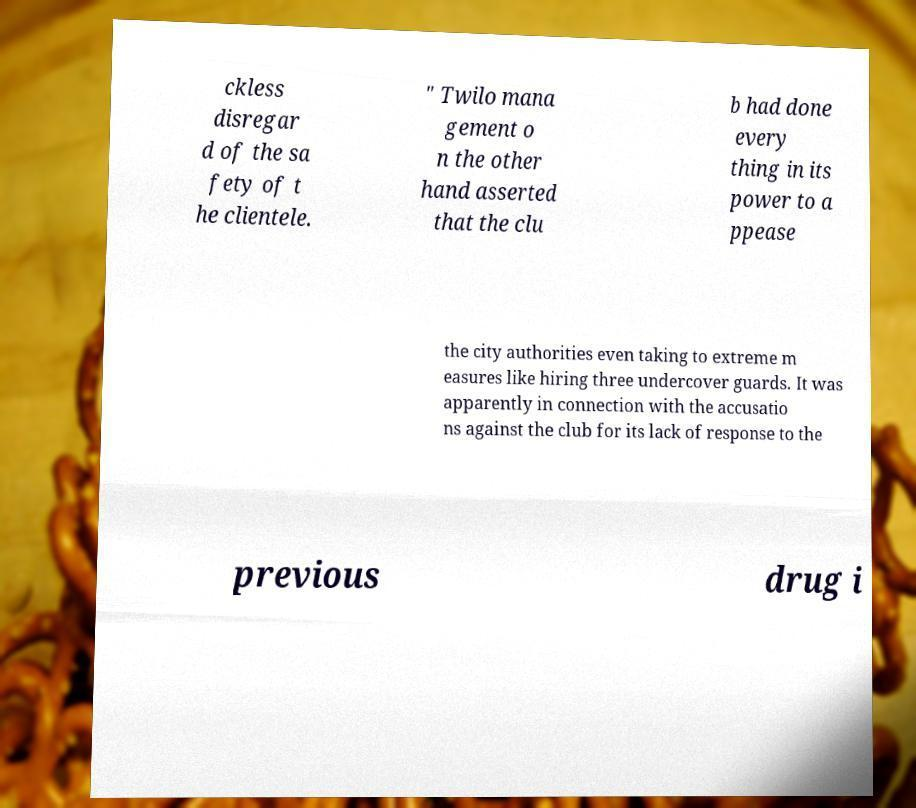Could you assist in decoding the text presented in this image and type it out clearly? ckless disregar d of the sa fety of t he clientele. " Twilo mana gement o n the other hand asserted that the clu b had done every thing in its power to a ppease the city authorities even taking to extreme m easures like hiring three undercover guards. It was apparently in connection with the accusatio ns against the club for its lack of response to the previous drug i 